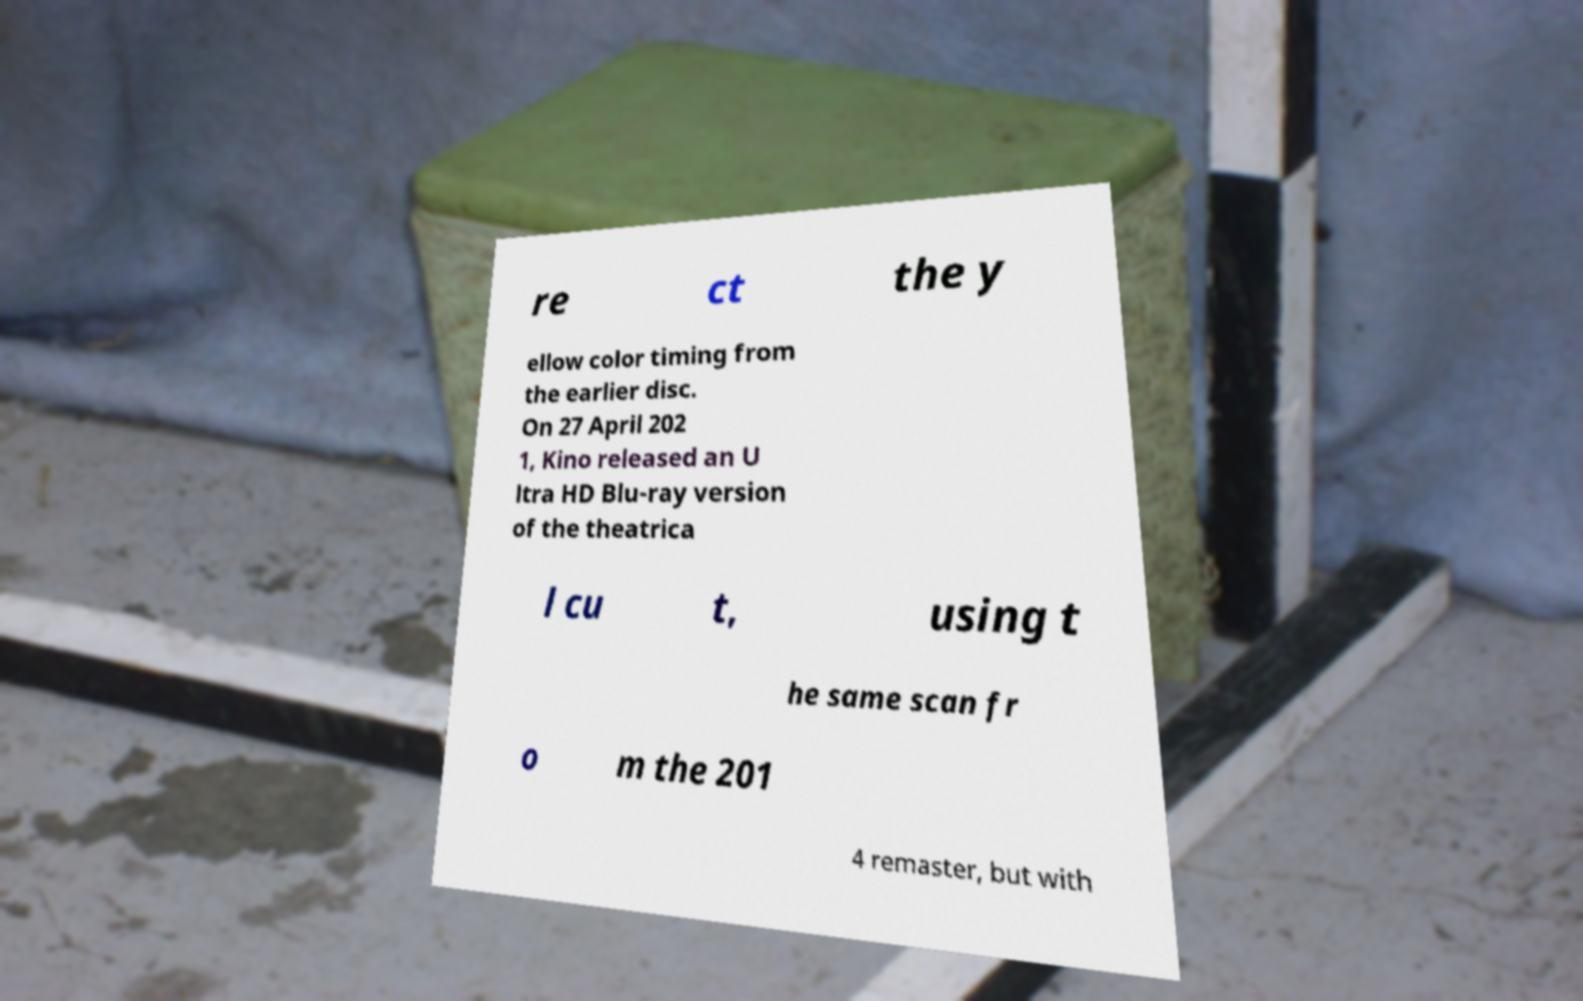Can you accurately transcribe the text from the provided image for me? re ct the y ellow color timing from the earlier disc. On 27 April 202 1, Kino released an U ltra HD Blu-ray version of the theatrica l cu t, using t he same scan fr o m the 201 4 remaster, but with 